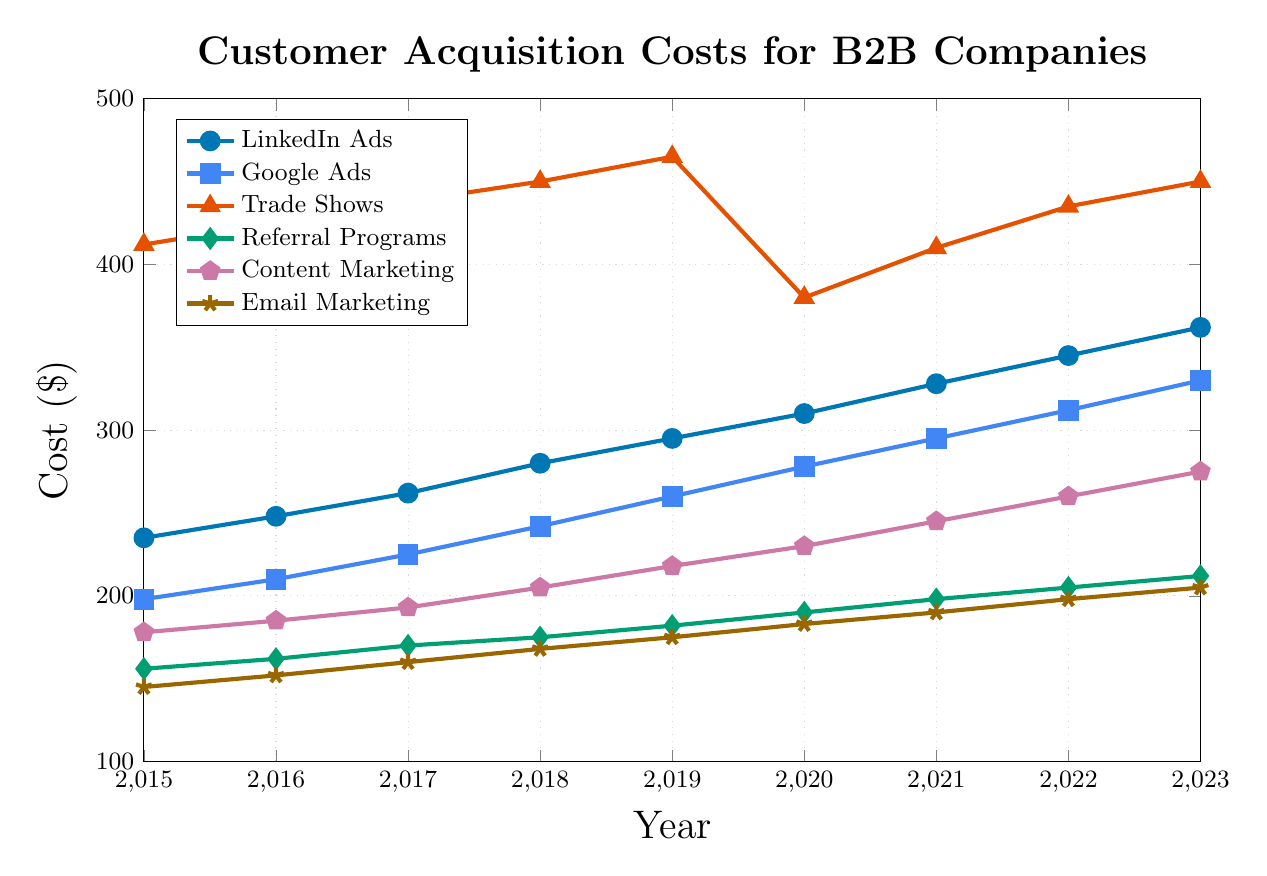What's the trend in Customer Acquisition Cost (CAC) for LinkedIn Ads from 2015 to 2023? Look at the LinkedIn Ads line (colored in blue) and observe the overall pattern. The costs consistently rise each year from 235 in 2015 to 362 in 2023.
Answer: The CAC for LinkedIn Ads has steadily increased Which marketing channel had the highest CAC in 2020, and what was its value? Identify the highest point on the vertical axis for 2020. Trade Shows have the highest CAC at 380.
Answer: Trade Shows, 380 How much did the CAC for Google Ads increase from 2015 to 2023? Subtract the value for Google Ads in 2015 (198) from the value in 2023 (330). The increase is 330 - 198 = 132.
Answer: 132 Between Referral Programs and Email Marketing, which marketing channel had a lower CAC in 2021, and by how much? The CAC for Referral Programs in 2021 was 198, and for Email Marketing, it was 190. The difference is 198 - 190 = 8. Email Marketing had a lower CAC.
Answer: Email Marketing, 8 What is the average CAC for Content Marketing from 2015 to 2023? Sum the CAC values for Content Marketing from 2015 to 2023 and divide by the number of years (9). The sum is 178 + 185 + 193 + 205 + 218 + 230 + 245 + 260 + 275 = 1989. The average is 1989/9 ≈ 221
Answer: 221 In which year did Trade Shows see a significant drop in CAC, and what possible reason could it be? Look for a sharp decrease in the Trade Shows line. In 2020, CAC significantly dropped from 465 in 2019 to 380, which could be due to the COVID-19 pandemic reducing physical event costs.
Answer: 2020, COVID-19 pandemic Which marketing channel showed the least variation in its CAC from 2015 to 2023? Compare the range of CAC values across the channels. Email Marketing varied from 145 to 205, which is a range of 60, whereas others had wider ranges.
Answer: Email Marketing How does the growth rate of CAC for LinkedIn Ads compare with Google Ads from 2015 to 2023? Calculate the percentage increase for both. LinkedIn Ads grew from 235 to 362, an increase of (362-235)/235 ≈ 54%. Google Ads grew from 198 to 330, an increase of (330-198)/198 ≈ 67%. Google Ads had a higher growth rate.
Answer: Google Ads In 2023, how much higher was the CAC for LinkedIn Ads compared to Content Marketing? The CAC for LinkedIn Ads in 2023 was 362, and for Content Marketing, it was 275. The difference is 362 - 275 = 87.
Answer: 87 Which marketing channel had the lowest CAC in 2018, and what was the cost? Identify the lowest point among all channels for 2018. Email Marketing had the lowest CAC at 168.
Answer: Email Marketing, 168 